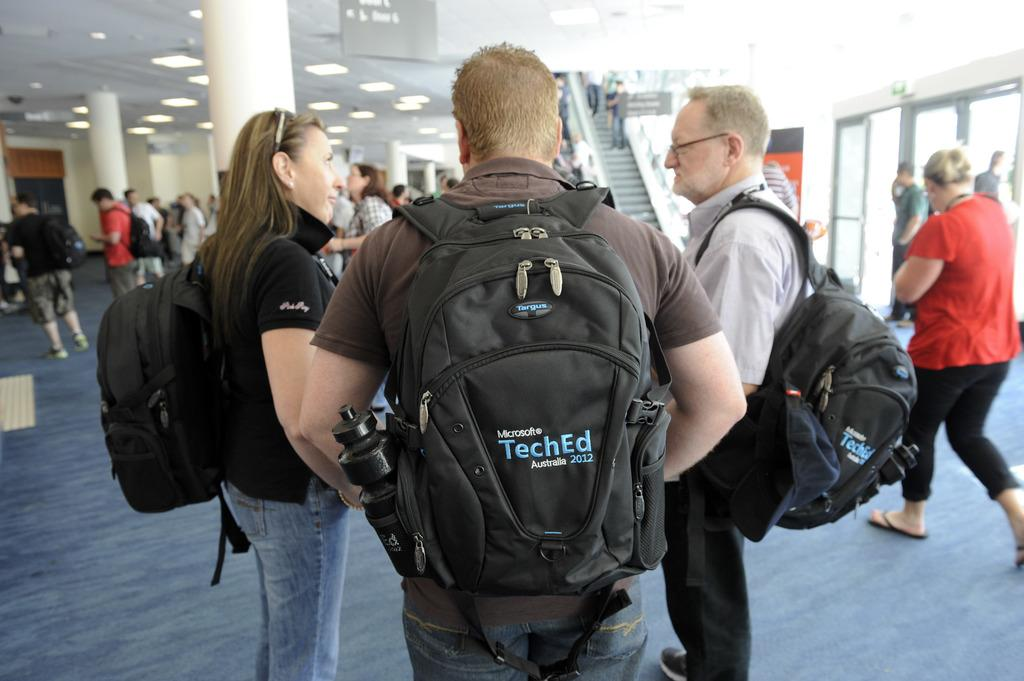<image>
Relay a brief, clear account of the picture shown. A man with the word "TechEd" on his backpack standing next to two other people 